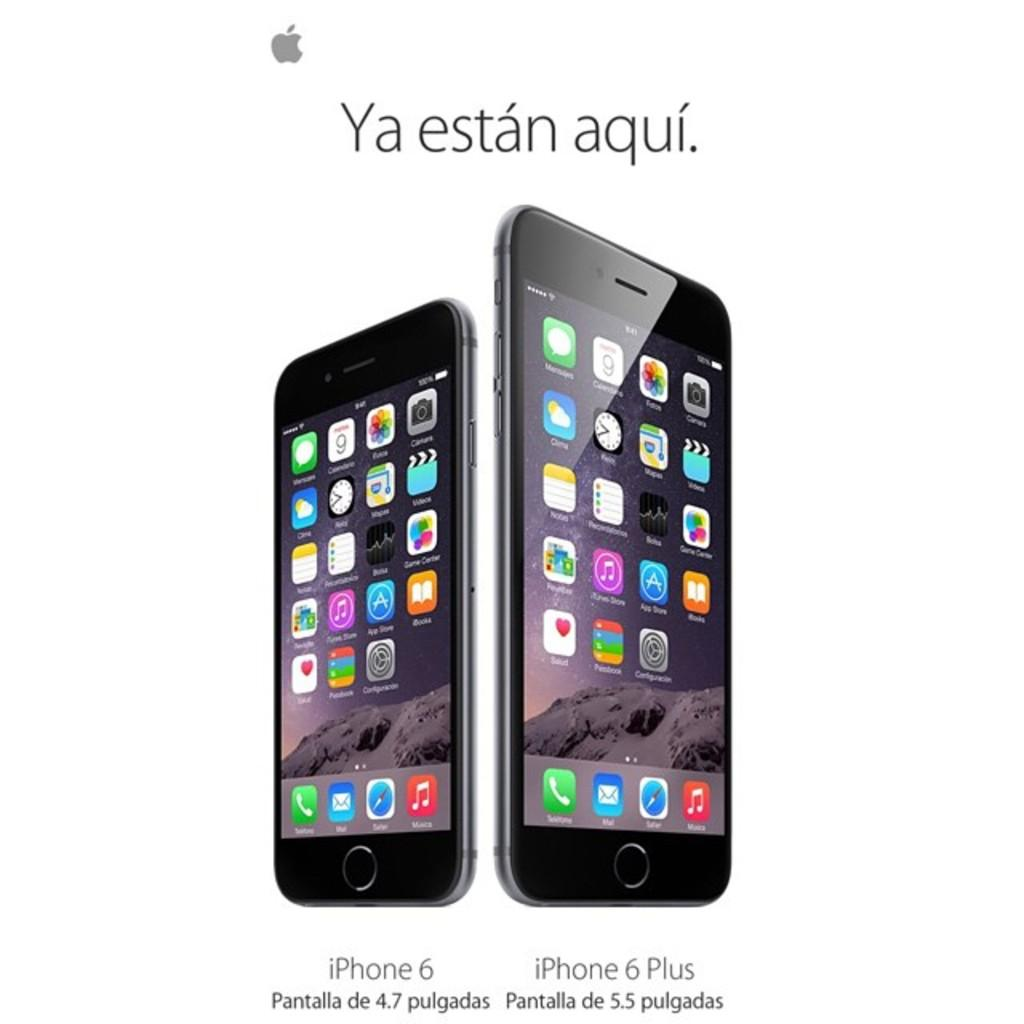Provide a one-sentence caption for the provided image. Two iphones side by side showing a comparison of size between them. 